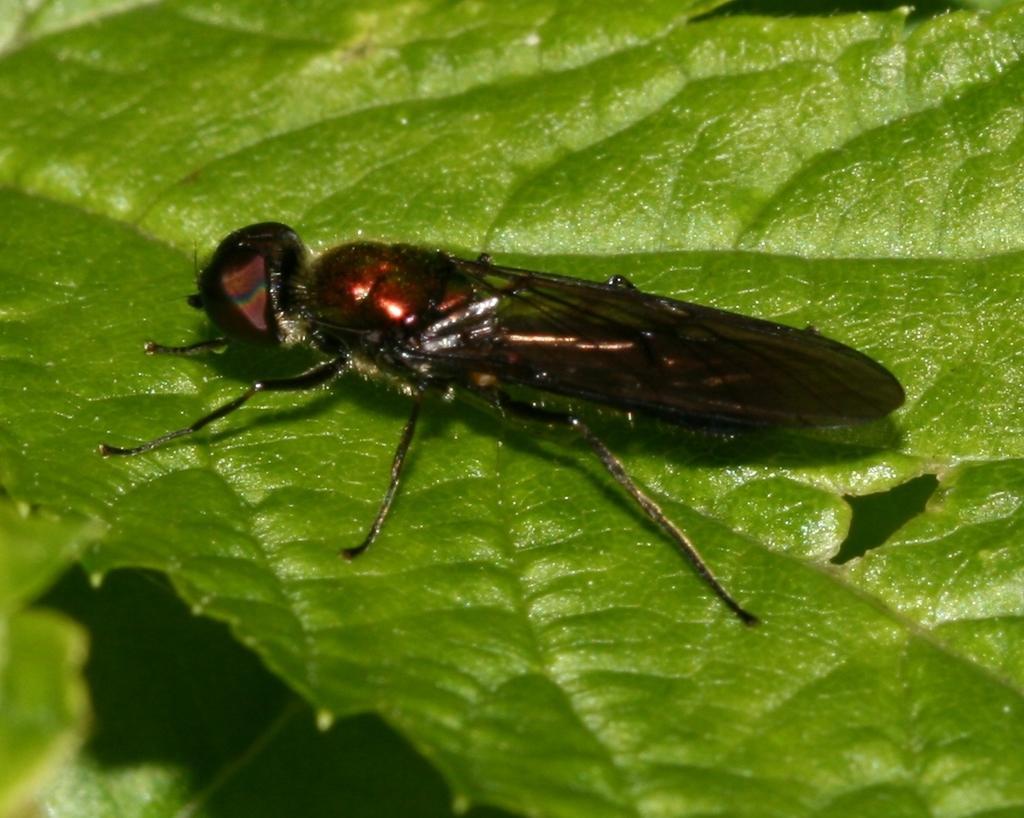Describe this image in one or two sentences. In the center of the image we can see leaves. On the leaf, we can see one insect, which is brown in color. 